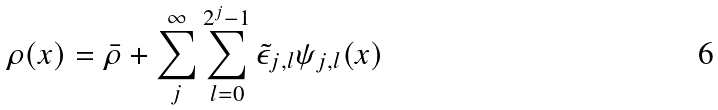<formula> <loc_0><loc_0><loc_500><loc_500>\rho ( { x } ) = \bar { \rho } + \sum _ { j } ^ { \infty } \sum _ { l = 0 } ^ { 2 ^ { j } - 1 } \tilde { \epsilon } _ { j , l } \psi _ { j , l } ( { x } )</formula> 